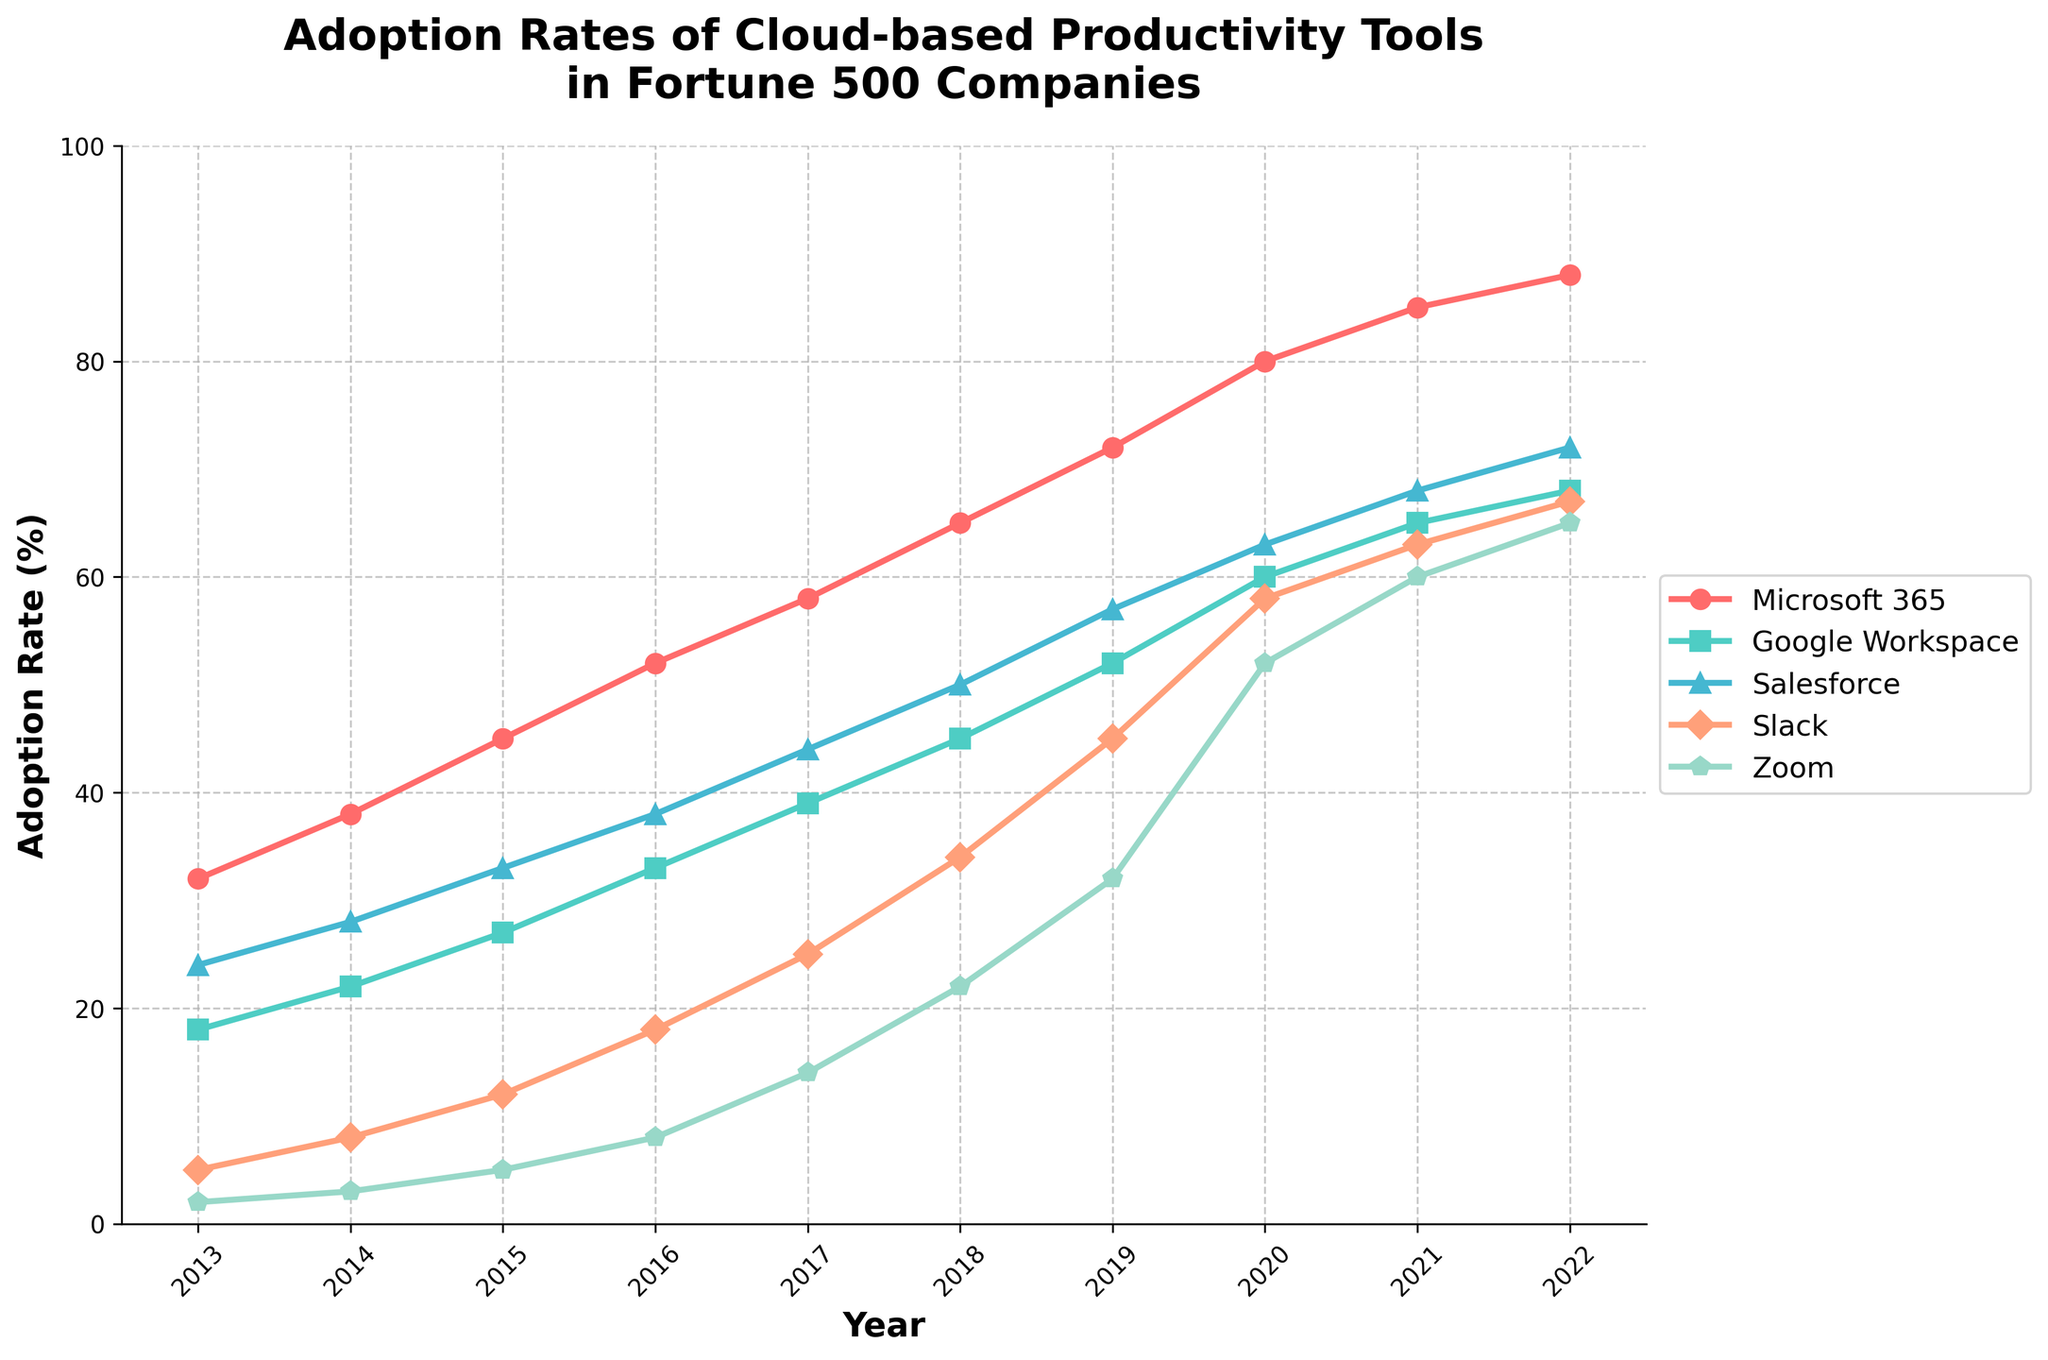What year did Microsoft 365 surpass a 50% adoption rate? From the graph, we observe that Microsoft 365 adoption rates hit 52% in the year 2016, which is the first time it surpasses 50%.
Answer: 2016 Which tool had the lowest adoption rate in 2018? Looking at the 2018 data points, Slack had an adoption rate of 34%, Microsoft 365 had 65%, Google Workspace had 45%, Salesforce had 50%, and Zoom had 22%. Zoom has the lowest adoption rate.
Answer: Zoom In which year did Google Workspace and Salesforce have the same adoption rate? Observing the graph, in both 2021, Google Workspace had 65% and Salesforce had 68%.
Answer: None What is the increase in adoption rate of Slack from 2014 to 2019? In 2014, Slack had an adoption rate of 8%. In 2019, it had an adoption rate of 45%. The increase is 45% - 8% = 37%.
Answer: 37% Which tool demonstrated the steepest increase in adoption from 2020 to 2021? Examining the lines, Slack went from 58% to 63%, Microsoft 365 went from 80% to 85%, Google Workspace went from 60% to 65%, Salesforce from 63% to 68%, and Zoom from 52% to 60%. The steepest increase is 8% for Zoom.
Answer: Zoom Among the tools, which tool had the highest adoption in the last year shown in the plot? Referencing the graph for 2022, adoption rates are Microsoft 365 (88%), Google Workspace (68%), Salesforce (72%), Slack (67%), and Zoom (65%). Microsoft 365 has the highest adoption rate.
Answer: Microsoft 365 In which year did Zoom's adoption rate surpass Slack's for the first time? Tracing the trend lines for Slack and Zoom, Zoom's adoption rate surpassed Slack's in the year 2020 (52% vs. 58%).
Answer: 2020 What’s the overall average adoption rate of Salesforce throughout the years shown? Summing up the adoption rates of Salesforce from 2013 to 2022 (24 + 28 + 33 + 38 + 44 + 50 + 57 + 63 + 68 + 72) gives a total of 477. Dividing by 10 years gives 477/10 = 47.7%.
Answer: 47.7% What is the total increase in adoption rate of Microsoft 365 from 2013 to 2022? Microsoft 365's adoption rate went from 32% in 2013 to 88% in 2022. The total increase is 88% - 32% = 56%.
Answer: 56% 